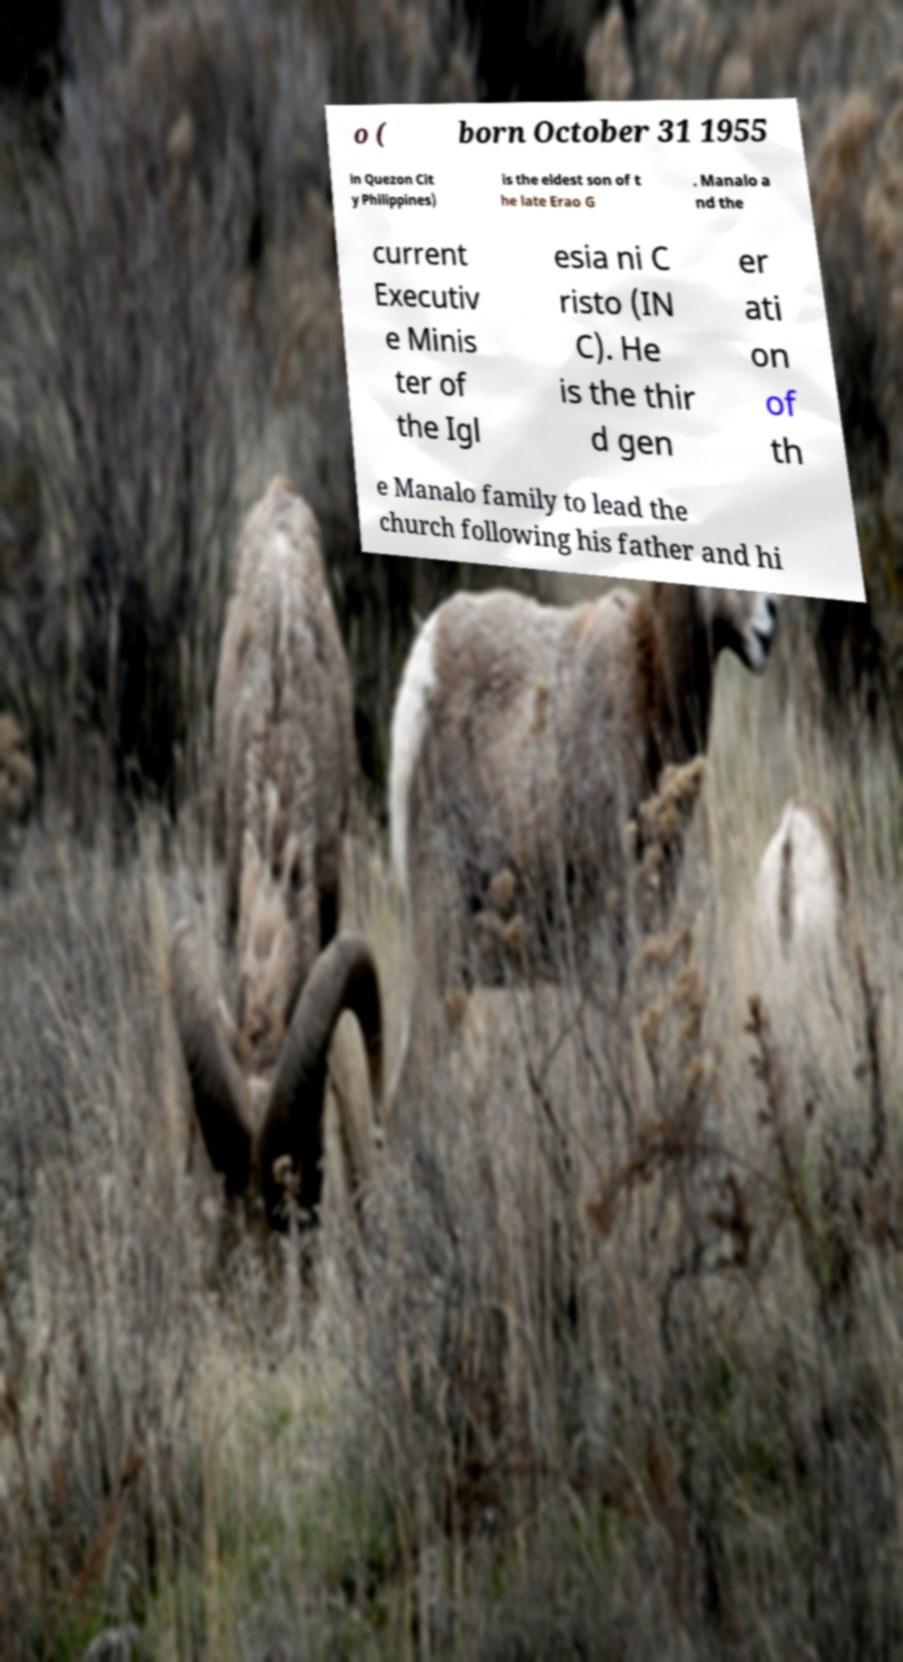Could you assist in decoding the text presented in this image and type it out clearly? o ( born October 31 1955 in Quezon Cit y Philippines) is the eldest son of t he late Erao G . Manalo a nd the current Executiv e Minis ter of the Igl esia ni C risto (IN C). He is the thir d gen er ati on of th e Manalo family to lead the church following his father and hi 